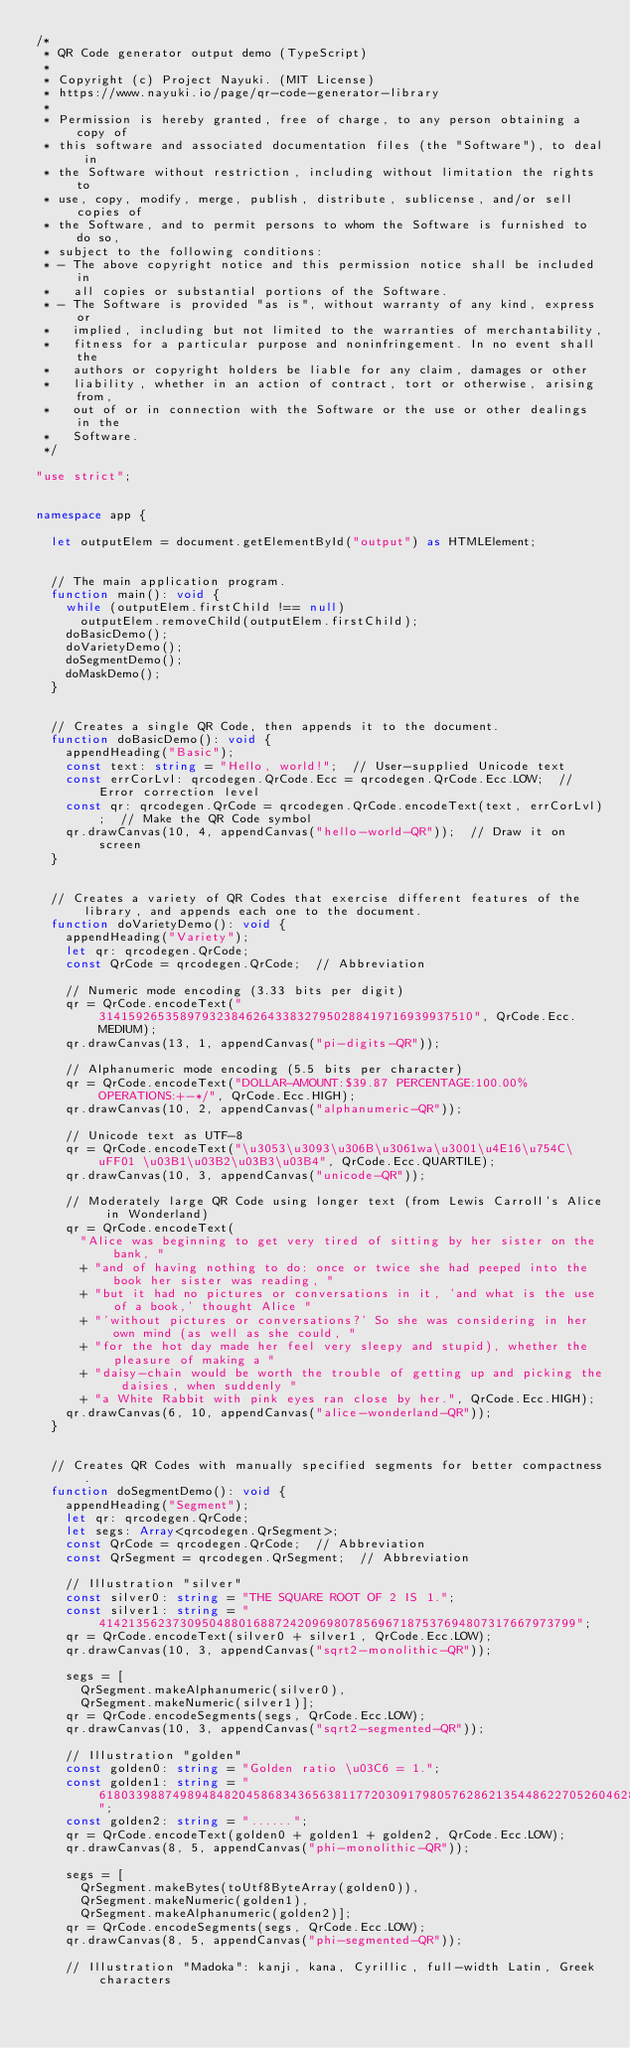<code> <loc_0><loc_0><loc_500><loc_500><_TypeScript_>/* 
 * QR Code generator output demo (TypeScript)
 * 
 * Copyright (c) Project Nayuki. (MIT License)
 * https://www.nayuki.io/page/qr-code-generator-library
 * 
 * Permission is hereby granted, free of charge, to any person obtaining a copy of
 * this software and associated documentation files (the "Software"), to deal in
 * the Software without restriction, including without limitation the rights to
 * use, copy, modify, merge, publish, distribute, sublicense, and/or sell copies of
 * the Software, and to permit persons to whom the Software is furnished to do so,
 * subject to the following conditions:
 * - The above copyright notice and this permission notice shall be included in
 *   all copies or substantial portions of the Software.
 * - The Software is provided "as is", without warranty of any kind, express or
 *   implied, including but not limited to the warranties of merchantability,
 *   fitness for a particular purpose and noninfringement. In no event shall the
 *   authors or copyright holders be liable for any claim, damages or other
 *   liability, whether in an action of contract, tort or otherwise, arising from,
 *   out of or in connection with the Software or the use or other dealings in the
 *   Software.
 */

"use strict";


namespace app {
	
	let outputElem = document.getElementById("output") as HTMLElement;
	
	
	// The main application program.
	function main(): void {
		while (outputElem.firstChild !== null)
			outputElem.removeChild(outputElem.firstChild);
		doBasicDemo();
		doVarietyDemo();
		doSegmentDemo();
		doMaskDemo();
	}
	
	
	// Creates a single QR Code, then appends it to the document.
	function doBasicDemo(): void {
		appendHeading("Basic");
		const text: string = "Hello, world!";  // User-supplied Unicode text
		const errCorLvl: qrcodegen.QrCode.Ecc = qrcodegen.QrCode.Ecc.LOW;  // Error correction level
		const qr: qrcodegen.QrCode = qrcodegen.QrCode.encodeText(text, errCorLvl);  // Make the QR Code symbol
		qr.drawCanvas(10, 4, appendCanvas("hello-world-QR"));  // Draw it on screen
	}
	
	
	// Creates a variety of QR Codes that exercise different features of the library, and appends each one to the document.
	function doVarietyDemo(): void {
		appendHeading("Variety");
		let qr: qrcodegen.QrCode;
		const QrCode = qrcodegen.QrCode;  // Abbreviation
		
		// Numeric mode encoding (3.33 bits per digit)
		qr = QrCode.encodeText("314159265358979323846264338327950288419716939937510", QrCode.Ecc.MEDIUM);
		qr.drawCanvas(13, 1, appendCanvas("pi-digits-QR"));
		
		// Alphanumeric mode encoding (5.5 bits per character)
		qr = QrCode.encodeText("DOLLAR-AMOUNT:$39.87 PERCENTAGE:100.00% OPERATIONS:+-*/", QrCode.Ecc.HIGH);
		qr.drawCanvas(10, 2, appendCanvas("alphanumeric-QR"));
		
		// Unicode text as UTF-8
		qr = QrCode.encodeText("\u3053\u3093\u306B\u3061wa\u3001\u4E16\u754C\uFF01 \u03B1\u03B2\u03B3\u03B4", QrCode.Ecc.QUARTILE);
		qr.drawCanvas(10, 3, appendCanvas("unicode-QR"));
		
		// Moderately large QR Code using longer text (from Lewis Carroll's Alice in Wonderland)
		qr = QrCode.encodeText(
			"Alice was beginning to get very tired of sitting by her sister on the bank, "
			+ "and of having nothing to do: once or twice she had peeped into the book her sister was reading, "
			+ "but it had no pictures or conversations in it, 'and what is the use of a book,' thought Alice "
			+ "'without pictures or conversations?' So she was considering in her own mind (as well as she could, "
			+ "for the hot day made her feel very sleepy and stupid), whether the pleasure of making a "
			+ "daisy-chain would be worth the trouble of getting up and picking the daisies, when suddenly "
			+ "a White Rabbit with pink eyes ran close by her.", QrCode.Ecc.HIGH);
		qr.drawCanvas(6, 10, appendCanvas("alice-wonderland-QR"));
	}
	
	
	// Creates QR Codes with manually specified segments for better compactness.
	function doSegmentDemo(): void {
		appendHeading("Segment");
		let qr: qrcodegen.QrCode;
		let segs: Array<qrcodegen.QrSegment>;
		const QrCode = qrcodegen.QrCode;  // Abbreviation
		const QrSegment = qrcodegen.QrSegment;  // Abbreviation
		
		// Illustration "silver"
		const silver0: string = "THE SQUARE ROOT OF 2 IS 1.";
		const silver1: string = "41421356237309504880168872420969807856967187537694807317667973799";
		qr = QrCode.encodeText(silver0 + silver1, QrCode.Ecc.LOW);
		qr.drawCanvas(10, 3, appendCanvas("sqrt2-monolithic-QR"));
		
		segs = [
			QrSegment.makeAlphanumeric(silver0),
			QrSegment.makeNumeric(silver1)];
		qr = QrCode.encodeSegments(segs, QrCode.Ecc.LOW);
		qr.drawCanvas(10, 3, appendCanvas("sqrt2-segmented-QR"));
		
		// Illustration "golden"
		const golden0: string = "Golden ratio \u03C6 = 1.";
		const golden1: string = "6180339887498948482045868343656381177203091798057628621354486227052604628189024497072072041893911374";
		const golden2: string = "......";
		qr = QrCode.encodeText(golden0 + golden1 + golden2, QrCode.Ecc.LOW);
		qr.drawCanvas(8, 5, appendCanvas("phi-monolithic-QR"));
		
		segs = [
			QrSegment.makeBytes(toUtf8ByteArray(golden0)),
			QrSegment.makeNumeric(golden1),
			QrSegment.makeAlphanumeric(golden2)];
		qr = QrCode.encodeSegments(segs, QrCode.Ecc.LOW);
		qr.drawCanvas(8, 5, appendCanvas("phi-segmented-QR"));
		
		// Illustration "Madoka": kanji, kana, Cyrillic, full-width Latin, Greek characters</code> 